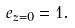Convert formula to latex. <formula><loc_0><loc_0><loc_500><loc_500>e _ { z = 0 } = 1 .</formula> 